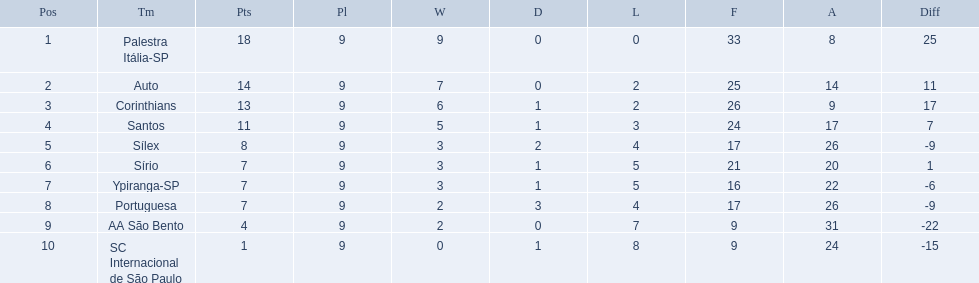Which teams were playing brazilian football in 1926? Palestra Itália-SP, Auto, Corinthians, Santos, Sílex, Sírio, Ypiranga-SP, Portuguesa, AA São Bento, SC Internacional de São Paulo. Of those teams, which one scored 13 points? Corinthians. 